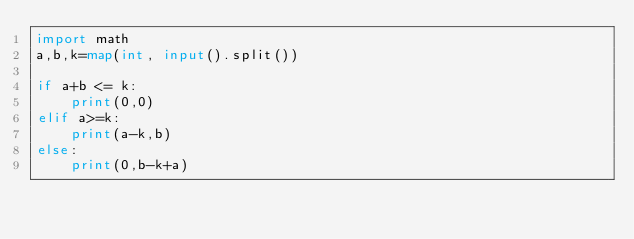<code> <loc_0><loc_0><loc_500><loc_500><_Python_>import math
a,b,k=map(int, input().split())

if a+b <= k:
    print(0,0)
elif a>=k:
    print(a-k,b)
else:
    print(0,b-k+a)</code> 